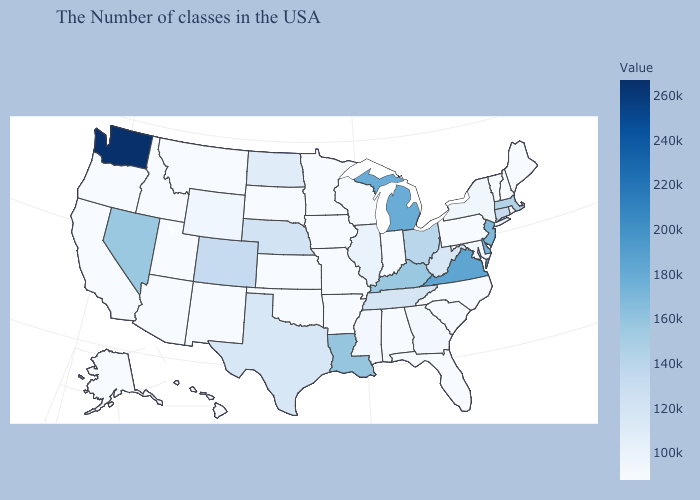Which states have the highest value in the USA?
Give a very brief answer. Washington. Among the states that border New Mexico , which have the lowest value?
Give a very brief answer. Oklahoma, Utah, Arizona. Does Michigan have the highest value in the MidWest?
Give a very brief answer. Yes. Among the states that border Montana , which have the highest value?
Quick response, please. North Dakota. 